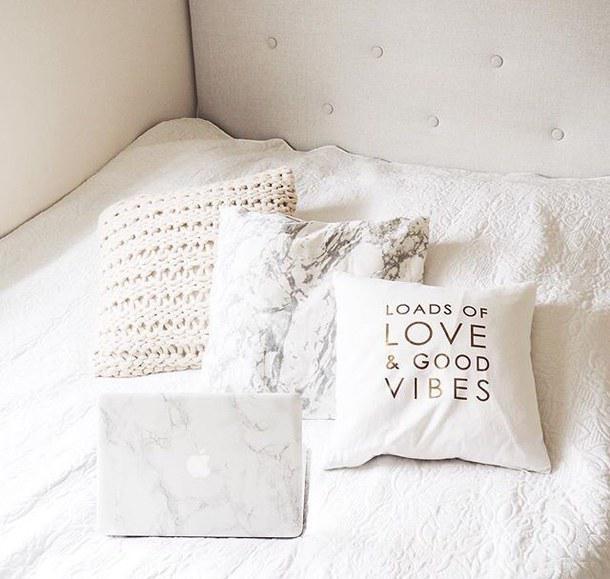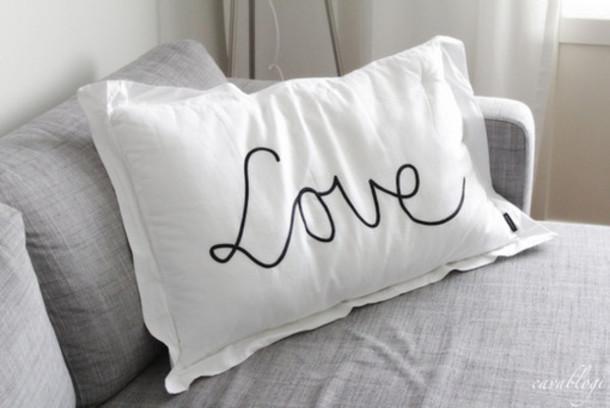The first image is the image on the left, the second image is the image on the right. Evaluate the accuracy of this statement regarding the images: "There are more pillows in the image on the left than in the image on the right.". Is it true? Answer yes or no. Yes. 